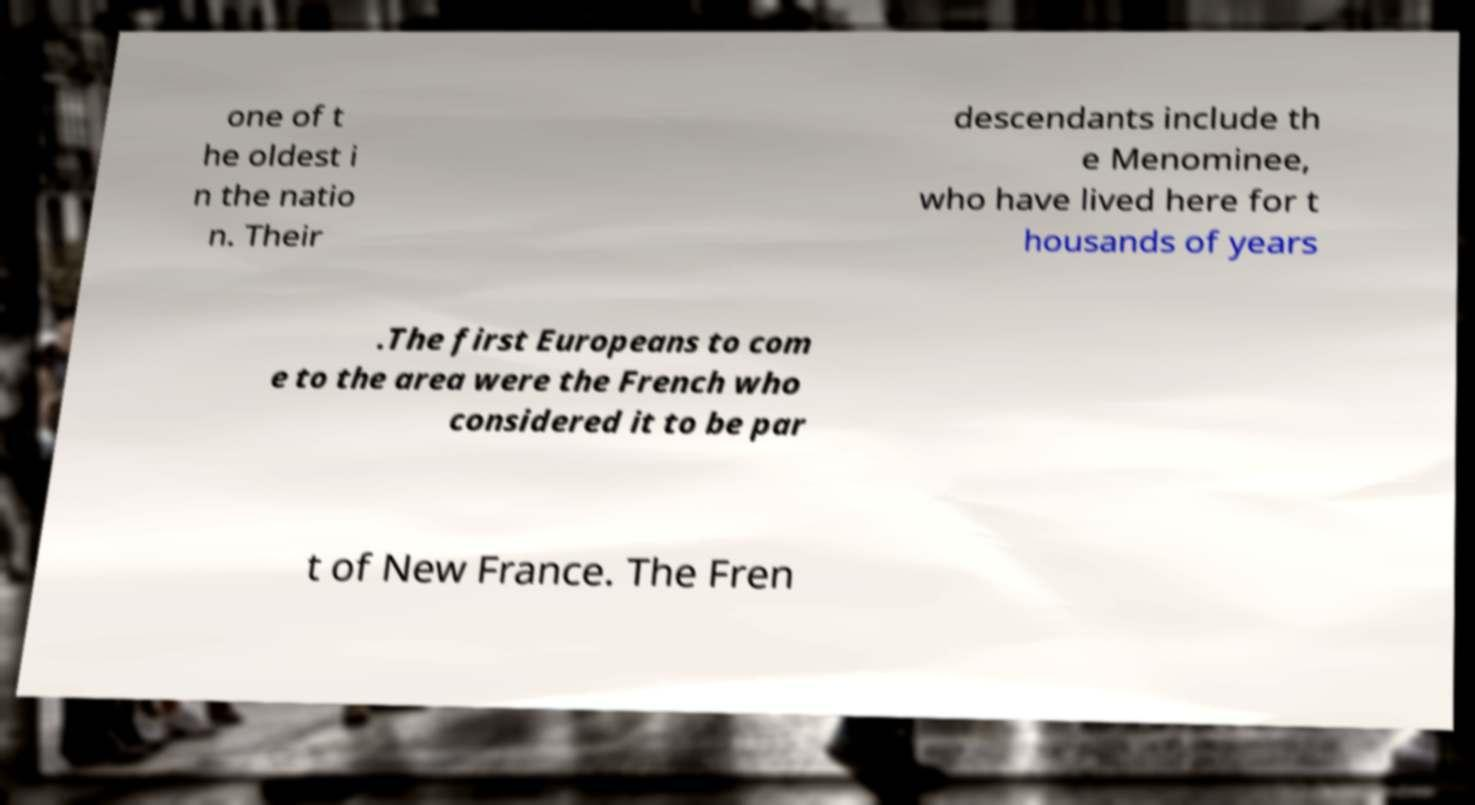There's text embedded in this image that I need extracted. Can you transcribe it verbatim? one of t he oldest i n the natio n. Their descendants include th e Menominee, who have lived here for t housands of years .The first Europeans to com e to the area were the French who considered it to be par t of New France. The Fren 